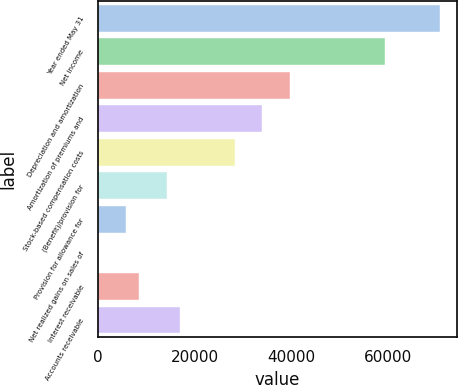Convert chart to OTSL. <chart><loc_0><loc_0><loc_500><loc_500><bar_chart><fcel>Year ended May 31<fcel>Net income<fcel>Depreciation and amortization<fcel>Amortization of premiums and<fcel>Stock-based compensation costs<fcel>(Benefit)/provision for<fcel>Provision for allowance for<fcel>Net realized gains on sales of<fcel>Interest receivable<fcel>Accounts receivable<nl><fcel>70830.6<fcel>59497.9<fcel>39665.6<fcel>33999.2<fcel>28332.8<fcel>14166.9<fcel>5667.28<fcel>0.9<fcel>8500.47<fcel>17000<nl></chart> 